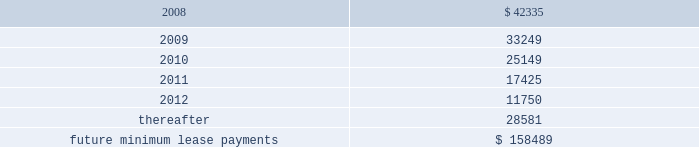Lkq corporation and subsidiaries notes to consolidated financial statements ( continued ) note 5 .
Long-term obligations ( continued ) as part of the consideration for business acquisitions completed during 2007 , 2006 and 2005 , we issued promissory notes totaling approximately $ 1.7 million , $ 7.2 million and $ 6.4 million , respectively .
The notes bear interest at annual rates of 3.0% ( 3.0 % ) to 6.0% ( 6.0 % ) , and interest is payable at maturity or in monthly installments .
We also assumed certain liabilities in connection with a business acquisition during the second quarter of 2005 , including a promissory note with a remaining principle balance of approximately $ 0.2 million .
The annual interest rate on the note , which was retired during 2006 , was note 6 .
Commitments and contingencies operating leases we are obligated under noncancelable operating leases for corporate office space , warehouse and distribution facilities , trucks and certain equipment .
The future minimum lease commitments under these leases at december 31 , 2007 are as follows ( in thousands ) : years ending december 31: .
Rental expense for operating leases was approximately $ 27.4 million , $ 18.6 million and $ 12.2 million during the years ended december 31 , 2007 , 2006 and 2005 , respectively .
We guaranty the residual values of the majority of our truck and equipment operating leases .
The residual values decline over the lease terms to a defined percentage of original cost .
In the event the lessor does not realize the residual value when a piece of equipment is sold , we would be responsible for a portion of the shortfall .
Similarly , if the lessor realizes more than the residual value when a piece of equipment is sold , we would be paid the amount realized over the residual value .
Had we terminated all of our operating leases subject to these guaranties at december 31 , 2007 , the guarantied residual value would have totaled approximately $ 24.0 million .
Litigation and related contingencies on december 2 , 2005 , ford global technologies , llc ( 2018 2018ford 2019 2019 ) filed a complaint with the united states international trade commission ( 2018 2018usitc 2019 2019 ) against keystone and five other named respondents , including four taiwan-based manufacturers .
On december 12 , 2005 , ford filed an amended complaint .
Both the complaint and the amended complaint contended that keystone and the other respondents infringed 14 design patents that ford alleges cover eight parts on the 2004-2005 .
What was the percentage change in rental expense from 2005 to 2006? 
Computations: ((18.6 - 12.2) / 12.2)
Answer: 0.52459. 